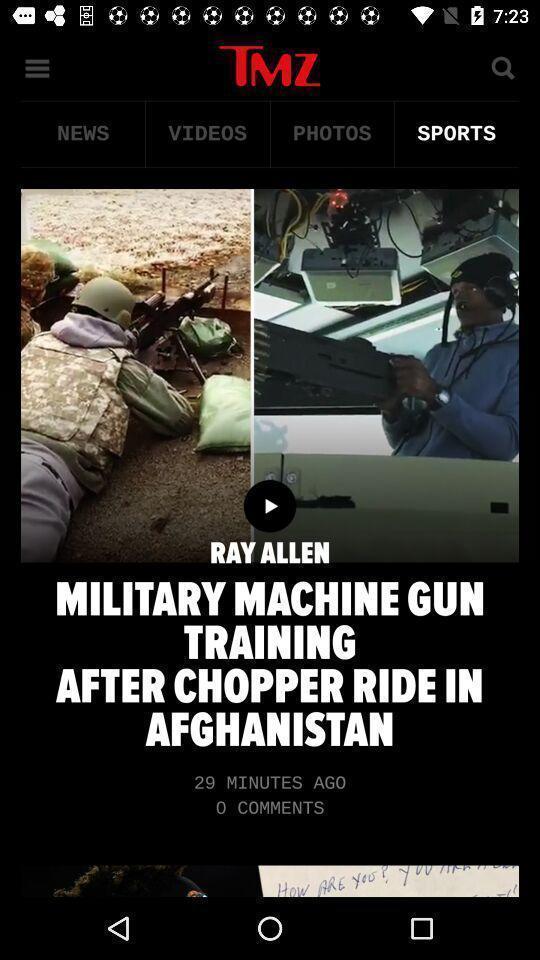Tell me about the visual elements in this screen capture. Sports news advertisement showing in this page. 